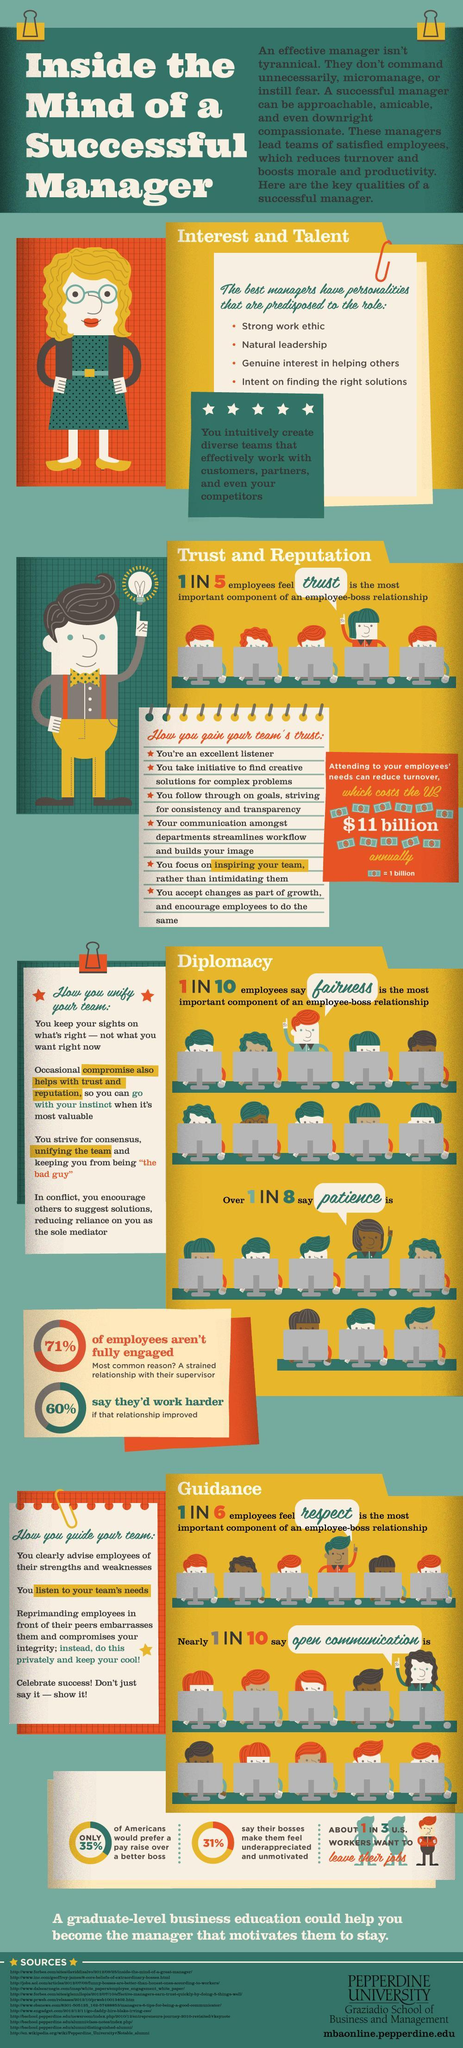what % of employees would show no improvement if relationship improved
Answer the question with a short phrase. 40 Fairness and Patience are which aspect of Managerial skills diplomacy what percentage of employees feel trust is the most important components of employee-boss relationship 20 What is the value of each currency note shown 1 billion respect and open communication are which aspect of managerial skills guidance what % prefer and pay rise over better boss and what % say their bosses make them feel underappreciated and unmotivated 35%, 31% what percentage of employees feel open communication is important 10 what percentage of employees feel fairness is the most important components of employee-boss relationship 10 